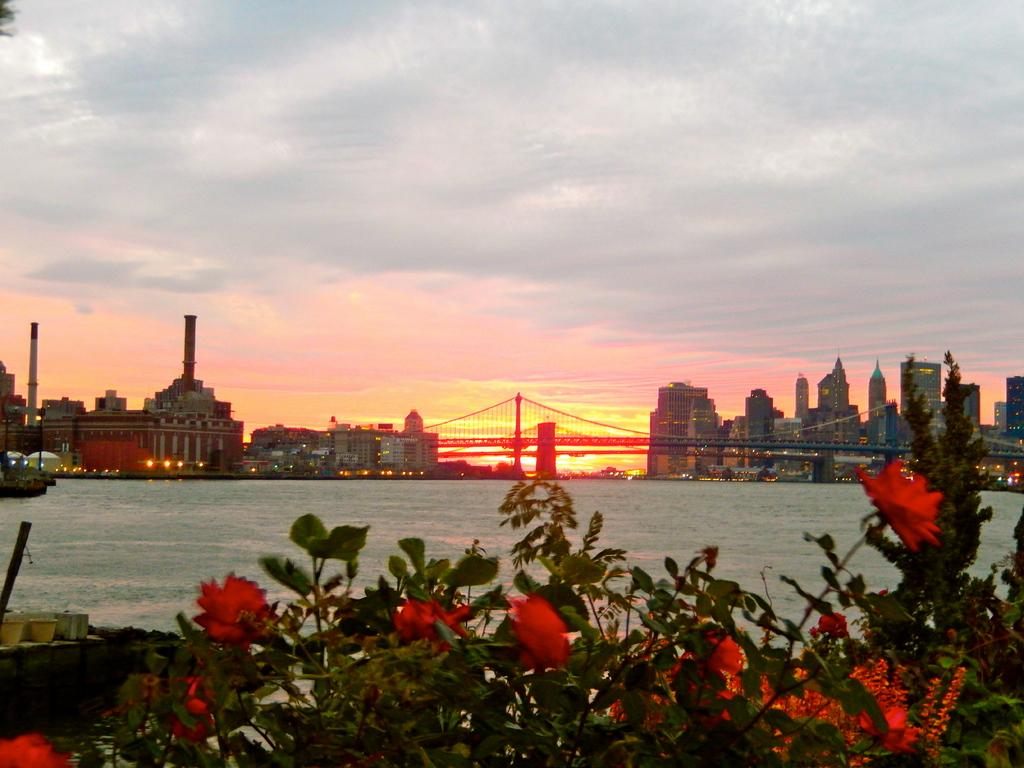What is located in the foreground of the image? There are plants with flowers in the foreground of the image. What can be seen in the background of the image? There are buildings and trees in the background of the image. What is visible in the image besides plants and buildings? There is water, a bridge, and a sky visible in the image. How many bears can be seen playing with an insect in the image? There are no bears or insects present in the image. 